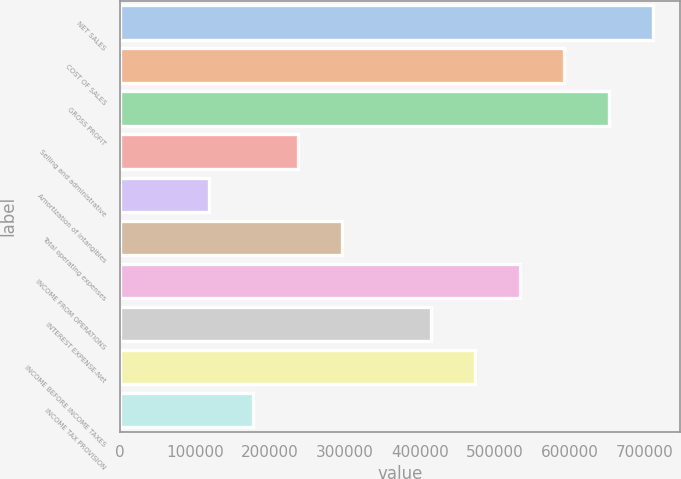<chart> <loc_0><loc_0><loc_500><loc_500><bar_chart><fcel>NET SALES<fcel>COST OF SALES<fcel>GROSS PROFIT<fcel>Selling and administrative<fcel>Amortization of intangibles<fcel>Total operating expenses<fcel>INCOME FROM OPERATIONS<fcel>INTEREST EXPENSE-Net<fcel>INCOME BEFORE INCOME TAXES<fcel>INCOME TAX PROVISION<nl><fcel>711357<fcel>592798<fcel>652078<fcel>237120<fcel>118561<fcel>296400<fcel>533518<fcel>414959<fcel>474239<fcel>177841<nl></chart> 